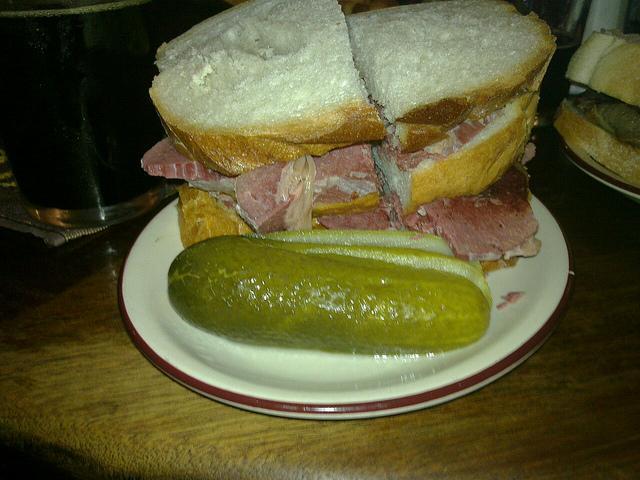What taste does the green food have?
Select the correct answer and articulate reasoning with the following format: 'Answer: answer
Rationale: rationale.'
Options: Sour, sweet, spicy, bitter. Answer: sour.
Rationale: The green food is a pickle. 